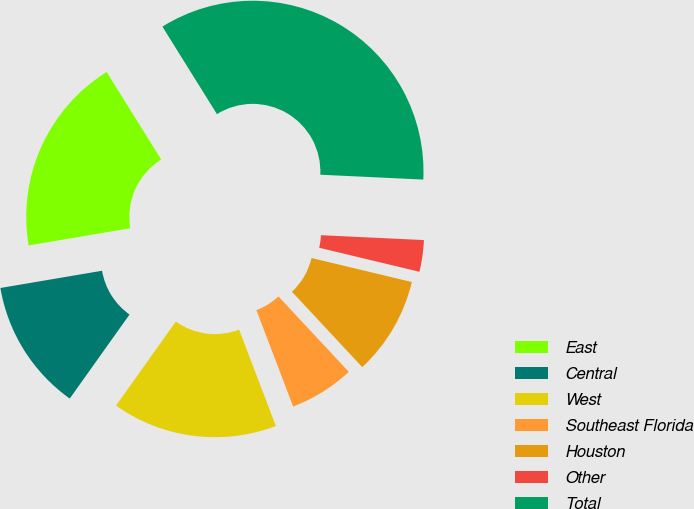<chart> <loc_0><loc_0><loc_500><loc_500><pie_chart><fcel>East<fcel>Central<fcel>West<fcel>Southeast Florida<fcel>Houston<fcel>Other<fcel>Total<nl><fcel>18.8%<fcel>12.48%<fcel>15.64%<fcel>6.15%<fcel>9.31%<fcel>2.99%<fcel>34.62%<nl></chart> 